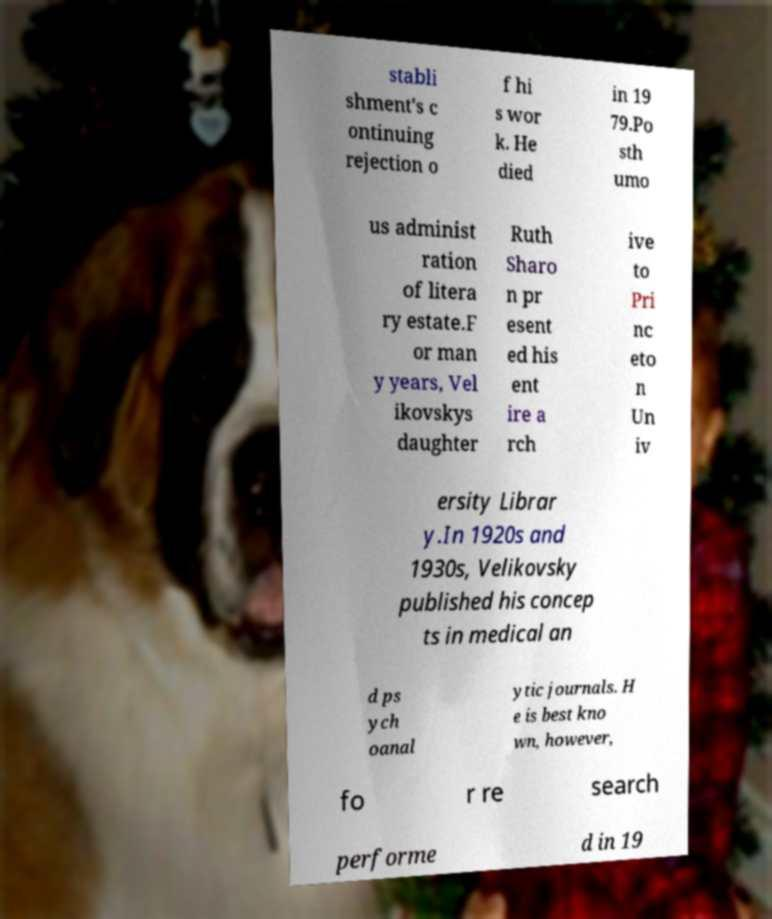For documentation purposes, I need the text within this image transcribed. Could you provide that? stabli shment's c ontinuing rejection o f hi s wor k. He died in 19 79.Po sth umo us administ ration of litera ry estate.F or man y years, Vel ikovskys daughter Ruth Sharo n pr esent ed his ent ire a rch ive to Pri nc eto n Un iv ersity Librar y.In 1920s and 1930s, Velikovsky published his concep ts in medical an d ps ych oanal ytic journals. H e is best kno wn, however, fo r re search performe d in 19 